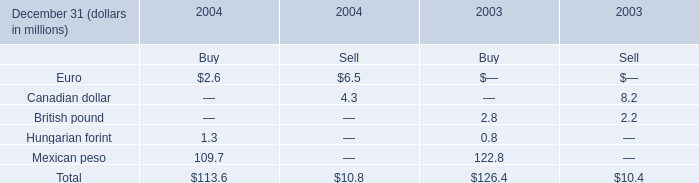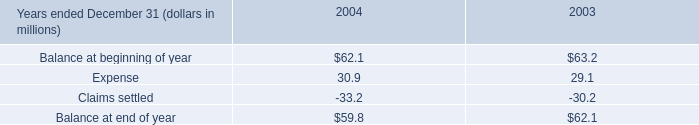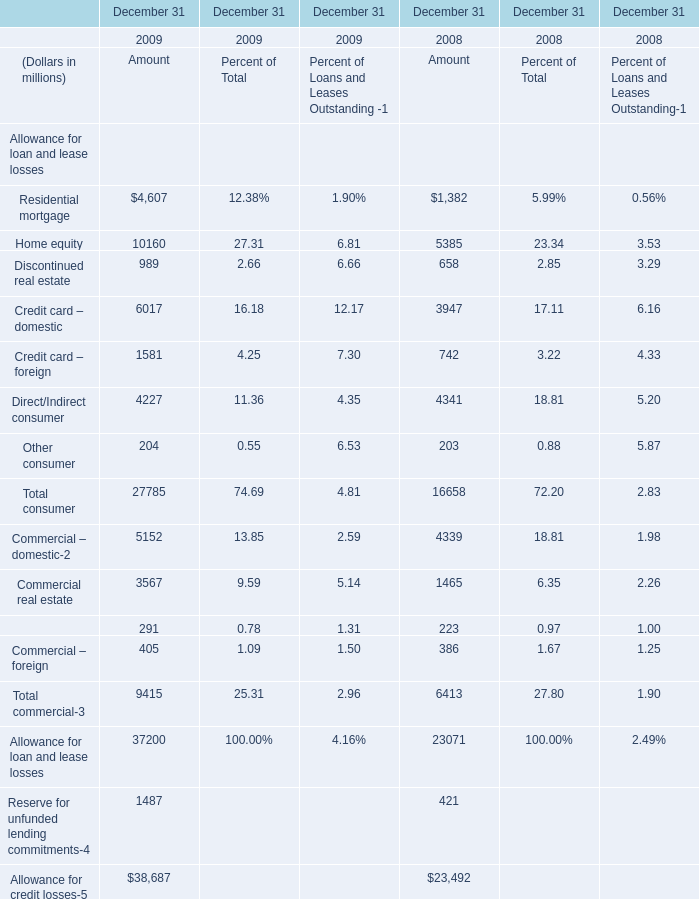In which year is Home equity for Amount positive? 
Answer: 2008 2009. 